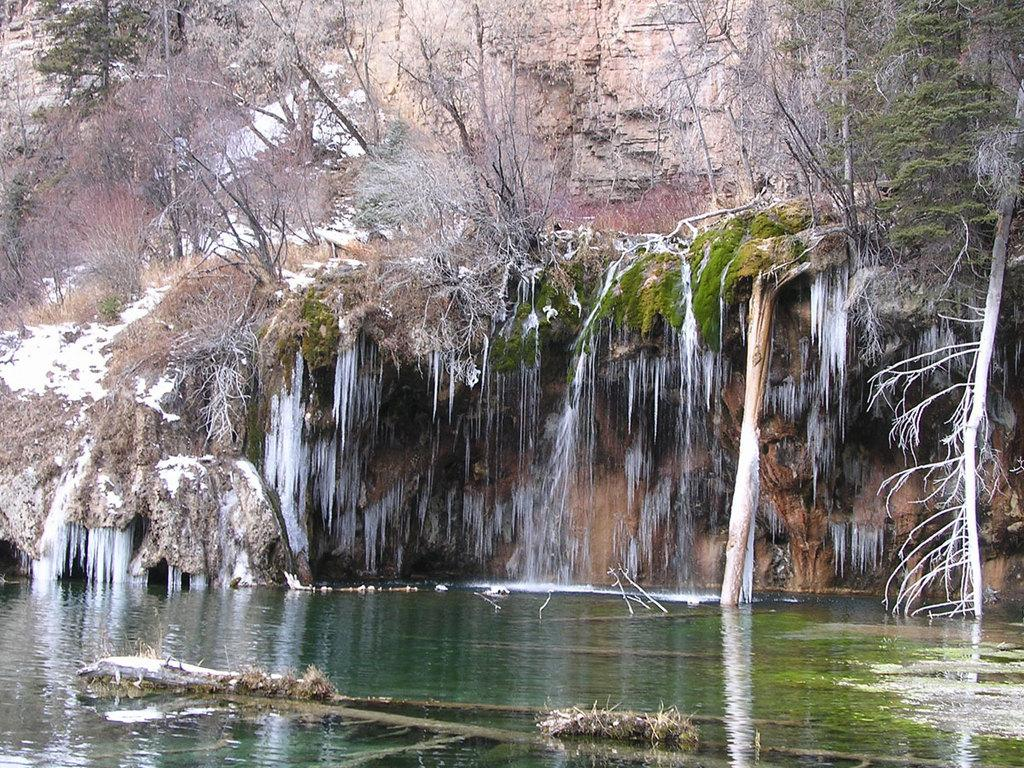What type of natural feature is at the top of the image? There is a mountain at the top of the image. What can be seen on the mountain in the image? There are trees on the mountain in the image. What is visible at the bottom of the image? There is water visible at the bottom of the image. What is the rate of religious conversion in the image? There is no information about religious conversion in the image, as it primarily features a mountain with trees and water at the bottom. 